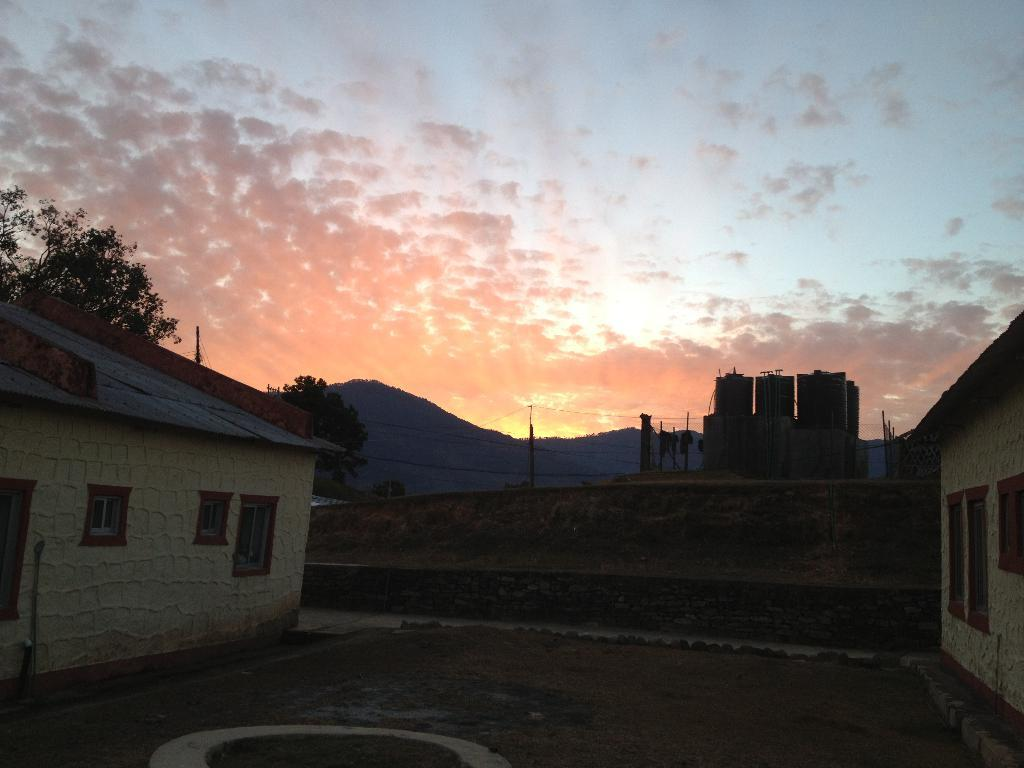How many houses are visible on each side of the image? There are two houses on the right side of the image and two houses on the left side of the image. What is located in the middle of the image? There is a land in the middle of the image. What can be seen in the background of the image? There are mountains, trees, and a blue sky in the background of the image. What type of mint is growing on the roof of the houses in the image? There is no mint visible on the roofs of the houses in the image. 